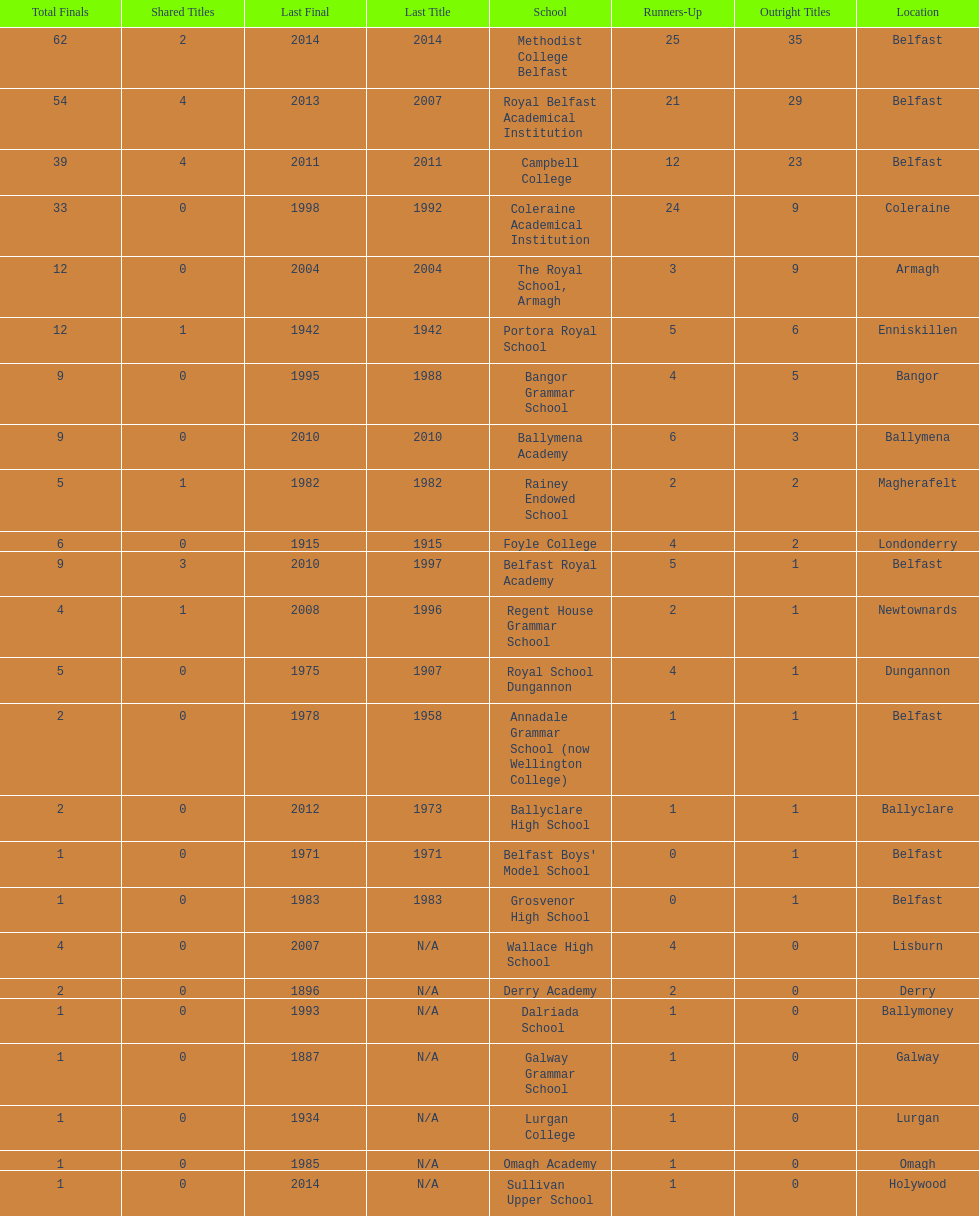When was the most recent year the regent house grammar school claimed a title? 1996. Write the full table. {'header': ['Total Finals', 'Shared Titles', 'Last Final', 'Last Title', 'School', 'Runners-Up', 'Outright Titles', 'Location'], 'rows': [['62', '2', '2014', '2014', 'Methodist College Belfast', '25', '35', 'Belfast'], ['54', '4', '2013', '2007', 'Royal Belfast Academical Institution', '21', '29', 'Belfast'], ['39', '4', '2011', '2011', 'Campbell College', '12', '23', 'Belfast'], ['33', '0', '1998', '1992', 'Coleraine Academical Institution', '24', '9', 'Coleraine'], ['12', '0', '2004', '2004', 'The Royal School, Armagh', '3', '9', 'Armagh'], ['12', '1', '1942', '1942', 'Portora Royal School', '5', '6', 'Enniskillen'], ['9', '0', '1995', '1988', 'Bangor Grammar School', '4', '5', 'Bangor'], ['9', '0', '2010', '2010', 'Ballymena Academy', '6', '3', 'Ballymena'], ['5', '1', '1982', '1982', 'Rainey Endowed School', '2', '2', 'Magherafelt'], ['6', '0', '1915', '1915', 'Foyle College', '4', '2', 'Londonderry'], ['9', '3', '2010', '1997', 'Belfast Royal Academy', '5', '1', 'Belfast'], ['4', '1', '2008', '1996', 'Regent House Grammar School', '2', '1', 'Newtownards'], ['5', '0', '1975', '1907', 'Royal School Dungannon', '4', '1', 'Dungannon'], ['2', '0', '1978', '1958', 'Annadale Grammar School (now Wellington College)', '1', '1', 'Belfast'], ['2', '0', '2012', '1973', 'Ballyclare High School', '1', '1', 'Ballyclare'], ['1', '0', '1971', '1971', "Belfast Boys' Model School", '0', '1', 'Belfast'], ['1', '0', '1983', '1983', 'Grosvenor High School', '0', '1', 'Belfast'], ['4', '0', '2007', 'N/A', 'Wallace High School', '4', '0', 'Lisburn'], ['2', '0', '1896', 'N/A', 'Derry Academy', '2', '0', 'Derry'], ['1', '0', '1993', 'N/A', 'Dalriada School', '1', '0', 'Ballymoney'], ['1', '0', '1887', 'N/A', 'Galway Grammar School', '1', '0', 'Galway'], ['1', '0', '1934', 'N/A', 'Lurgan College', '1', '0', 'Lurgan'], ['1', '0', '1985', 'N/A', 'Omagh Academy', '1', '0', 'Omagh'], ['1', '0', '2014', 'N/A', 'Sullivan Upper School', '1', '0', 'Holywood']]} 